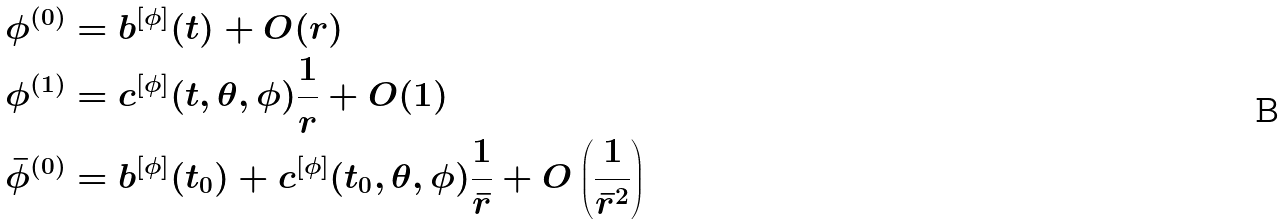Convert formula to latex. <formula><loc_0><loc_0><loc_500><loc_500>\phi ^ { ( 0 ) } & = b ^ { [ \phi ] } ( t ) + O ( r ) \\ \phi ^ { ( 1 ) } & = c ^ { [ \phi ] } ( t , \theta , \phi ) \frac { 1 } { r } + O ( 1 ) \\ \bar { \phi } ^ { ( 0 ) } & = b ^ { [ \phi ] } ( t _ { 0 } ) + c ^ { [ \phi ] } ( t _ { 0 } , \theta , \phi ) \frac { 1 } { \bar { r } } + O \left ( \frac { 1 } { \bar { r } ^ { 2 } } \right )</formula> 